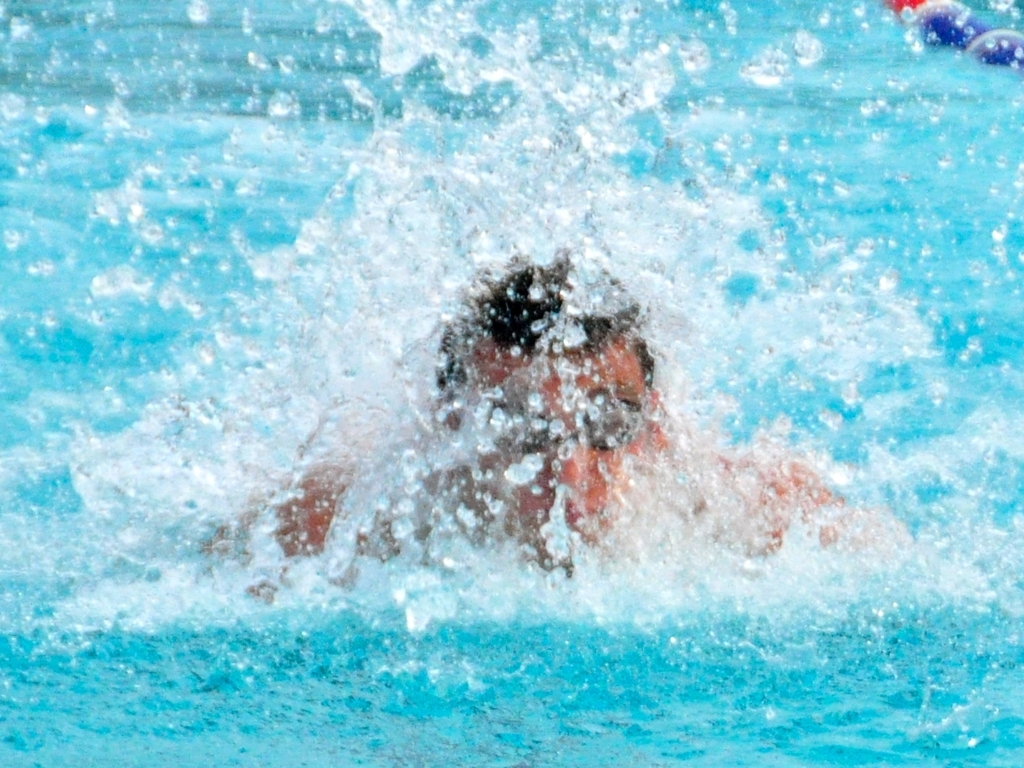Can you tell how experienced the swimmer might be from this photo? While it's difficult to assess the entire skill level from a single image, the significant splash and visible muscular tension suggest that the swimmer is applying considerable force and speed, which are characteristics often associated with more experienced swimmers. 